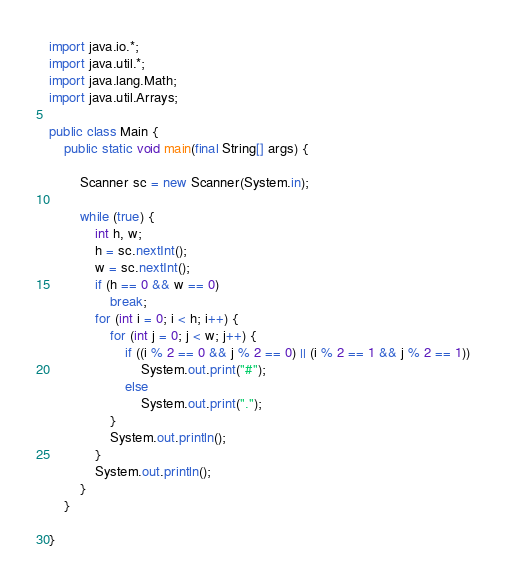Convert code to text. <code><loc_0><loc_0><loc_500><loc_500><_Java_>import java.io.*;
import java.util.*;
import java.lang.Math;
import java.util.Arrays;

public class Main {
    public static void main(final String[] args) {

        Scanner sc = new Scanner(System.in);

        while (true) {
            int h, w;
            h = sc.nextInt();
            w = sc.nextInt();
            if (h == 0 && w == 0)
                break;
            for (int i = 0; i < h; i++) {
                for (int j = 0; j < w; j++) {
                    if ((i % 2 == 0 && j % 2 == 0) || (i % 2 == 1 && j % 2 == 1))
                        System.out.print("#");
                    else
                        System.out.print(".");
                }
                System.out.println();
            }
            System.out.println();
        }
    }
  
}
</code> 